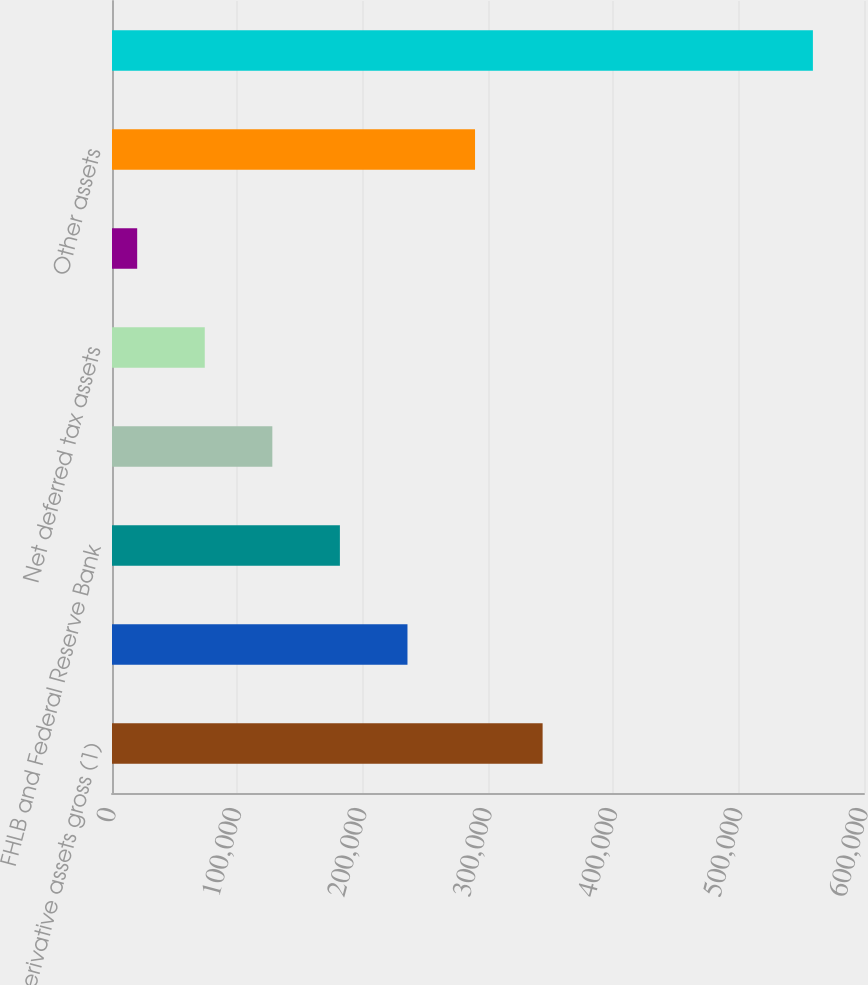Convert chart to OTSL. <chart><loc_0><loc_0><loc_500><loc_500><bar_chart><fcel>Derivative assets gross (1)<fcel>Accrued interest receivable<fcel>FHLB and Federal Reserve Bank<fcel>Foreign exchange spot contract<fcel>Net deferred tax assets<fcel>Accounts receivable<fcel>Other assets<fcel>Total accrued interest<nl><fcel>343575<fcel>235748<fcel>181834<fcel>127920<fcel>74005.9<fcel>20092<fcel>289662<fcel>559231<nl></chart> 